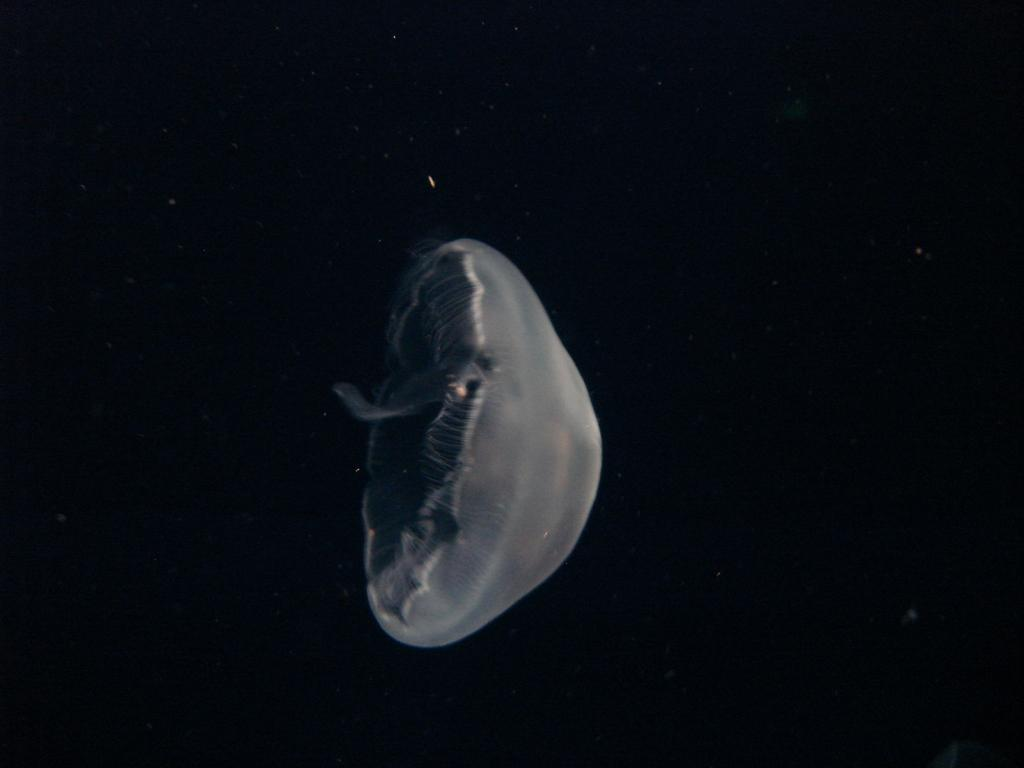What type of sea creature is in the image? There is a jellyfish in the image. What type of paper can be seen in the image? There is no paper present in the image; it features a jellyfish. Can you see any fairies flying around the jellyfish in the image? There are no fairies present in the image; it features a jellyfish. 